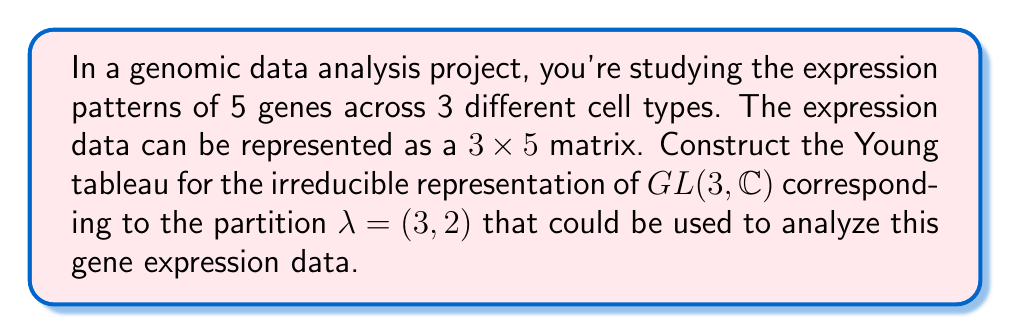Help me with this question. To construct the Young tableau for the irreducible representation of $GL(3, \mathbb{C})$ corresponding to the partition $\lambda = (3,2)$, we follow these steps:

1. Understand the partition:
   $\lambda = (3,2)$ means we need to create a diagram with two rows:
   - First row has 3 boxes
   - Second row has 2 boxes

2. Create the Young diagram:
   ```
   [ ][ ][ ]
   [ ][ ]
   ```

3. Fill the Young diagram to create a standard Young tableau:
   - We have 3 rows in our gene expression matrix (3 cell types), so we use numbers 1, 2, and 3
   - Fill the boxes in ascending order, ensuring each row and column is strictly increasing
   
4. The resulting standard Young tableau:
   ```
   [1][2][3]
   [2][3]
   ```

This Young tableau represents how the irreducible representation of $GL(3, \mathbb{C})$ corresponding to $\lambda = (3,2)$ can be used to analyze the gene expression patterns across the 3 cell types.

In the context of gene expression analysis:
- Each row represents a different way to select cell types for comparison
- The first row (1,2,3) represents comparing all three cell types
- The second row (2,3) represents comparing only the second and third cell types

This representation can help in identifying symmetries and patterns in the gene expression data across different cell types.
Answer: $$\young(123,23)$$ 